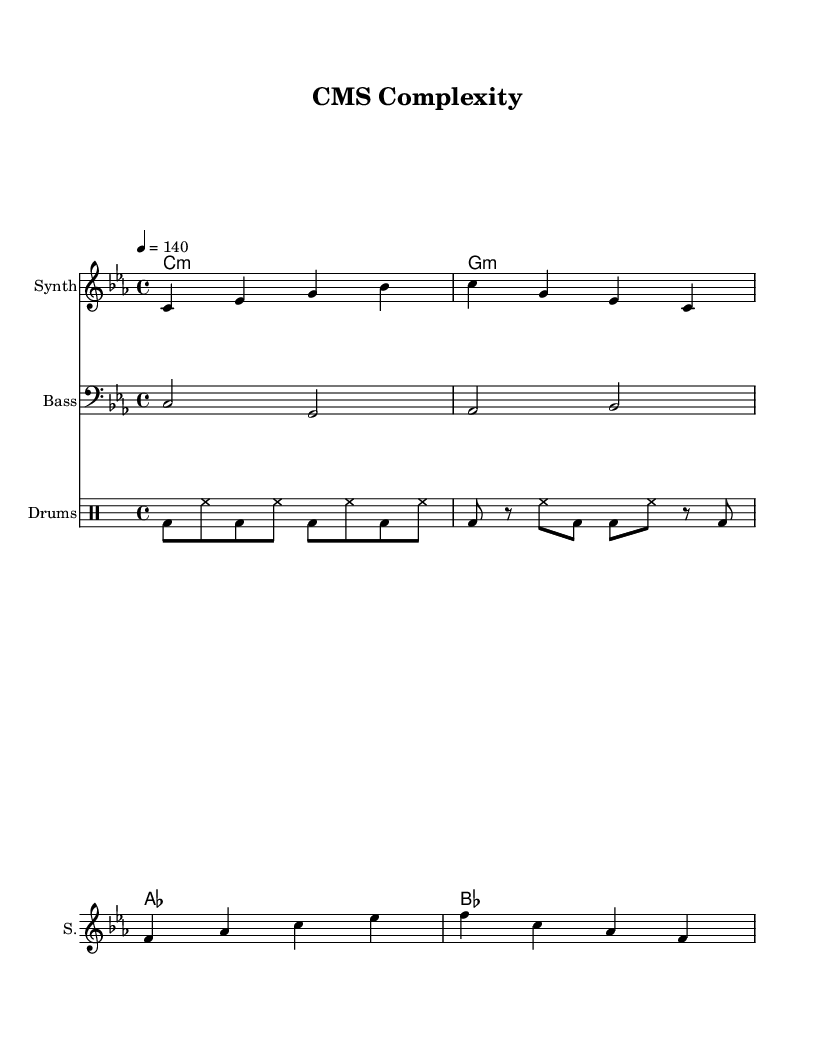What is the key signature of this music? The key signature is C minor, which is represented by three flats (B♭, E♭, and A♭). It is indicated at the beginning of the staff.
Answer: C minor What is the time signature of this music? The time signature is indicated at the beginning of the piece, where it is displayed as 4/4. This means there are four beats in each measure and the quarter note gets one beat.
Answer: 4/4 What is the tempo marking for this piece? The tempo marking is shown as "4 = 140," which indicates that the quarter note should be played at a speed of 140 beats per minute.
Answer: 140 How many measures does the synth melody consist of? Counting the measures in the synth melody from the provided sheet music, we can see there are a total of four measures.
Answer: 4 What is the first note of the bassline? The first note of the bassline is C, which is the first note indicated in the bassline section. It is played as a half note.
Answer: C In which part does the drum section primarily feature bass drums? The drum section uses bass drums predominantly in the first and third beats of each measure, which is typical for rhythmic patterns in electronic music.
Answer: Drums What type of chords are indicated in the chord names? The chord names in the score consist of minor chords and are indicated by a colon (:) following the chord letter, specifically C minor and G minor.
Answer: Minor chords 